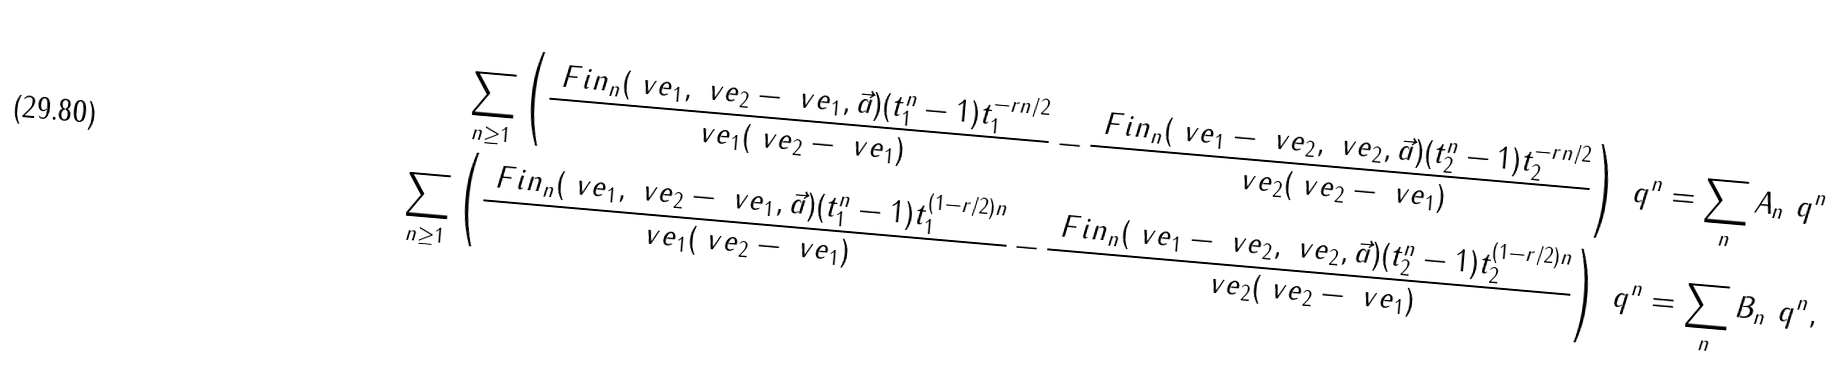Convert formula to latex. <formula><loc_0><loc_0><loc_500><loc_500>\sum _ { n \geq 1 } \left ( \frac { \ F i n _ { n } ( \ v e _ { 1 } , \ v e _ { 2 } - \ v e _ { 1 } , \vec { a } ) ( t _ { 1 } ^ { n } - 1 ) t _ { 1 } ^ { - r n / 2 } } { \ v e _ { 1 } ( \ v e _ { 2 } - \ v e _ { 1 } ) } - \frac { \ F i n _ { n } ( \ v e _ { 1 } - \ v e _ { 2 } , \ v e _ { 2 } , \vec { a } ) ( t _ { 2 } ^ { n } - 1 ) t _ { 2 } ^ { - r n / 2 } } { \ v e _ { 2 } ( \ v e _ { 2 } - \ v e _ { 1 } ) } \right ) \ q ^ { n } = \sum _ { n } A _ { n } \ q ^ { n } \\ \sum _ { n \geq 1 } \left ( \frac { \ F i n _ { n } ( \ v e _ { 1 } , \ v e _ { 2 } - \ v e _ { 1 } , \vec { a } ) ( t _ { 1 } ^ { n } - 1 ) t _ { 1 } ^ { ( 1 - r / 2 ) n } } { \ v e _ { 1 } ( \ v e _ { 2 } - \ v e _ { 1 } ) } - \frac { \ F i n _ { n } ( \ v e _ { 1 } - \ v e _ { 2 } , \ v e _ { 2 } , \vec { a } ) ( t _ { 2 } ^ { n } - 1 ) t _ { 2 } ^ { ( 1 - r / 2 ) n } } { \ v e _ { 2 } ( \ v e _ { 2 } - \ v e _ { 1 } ) } \right ) \ q ^ { n } = \sum _ { n } B _ { n } \ q ^ { n } ,</formula> 